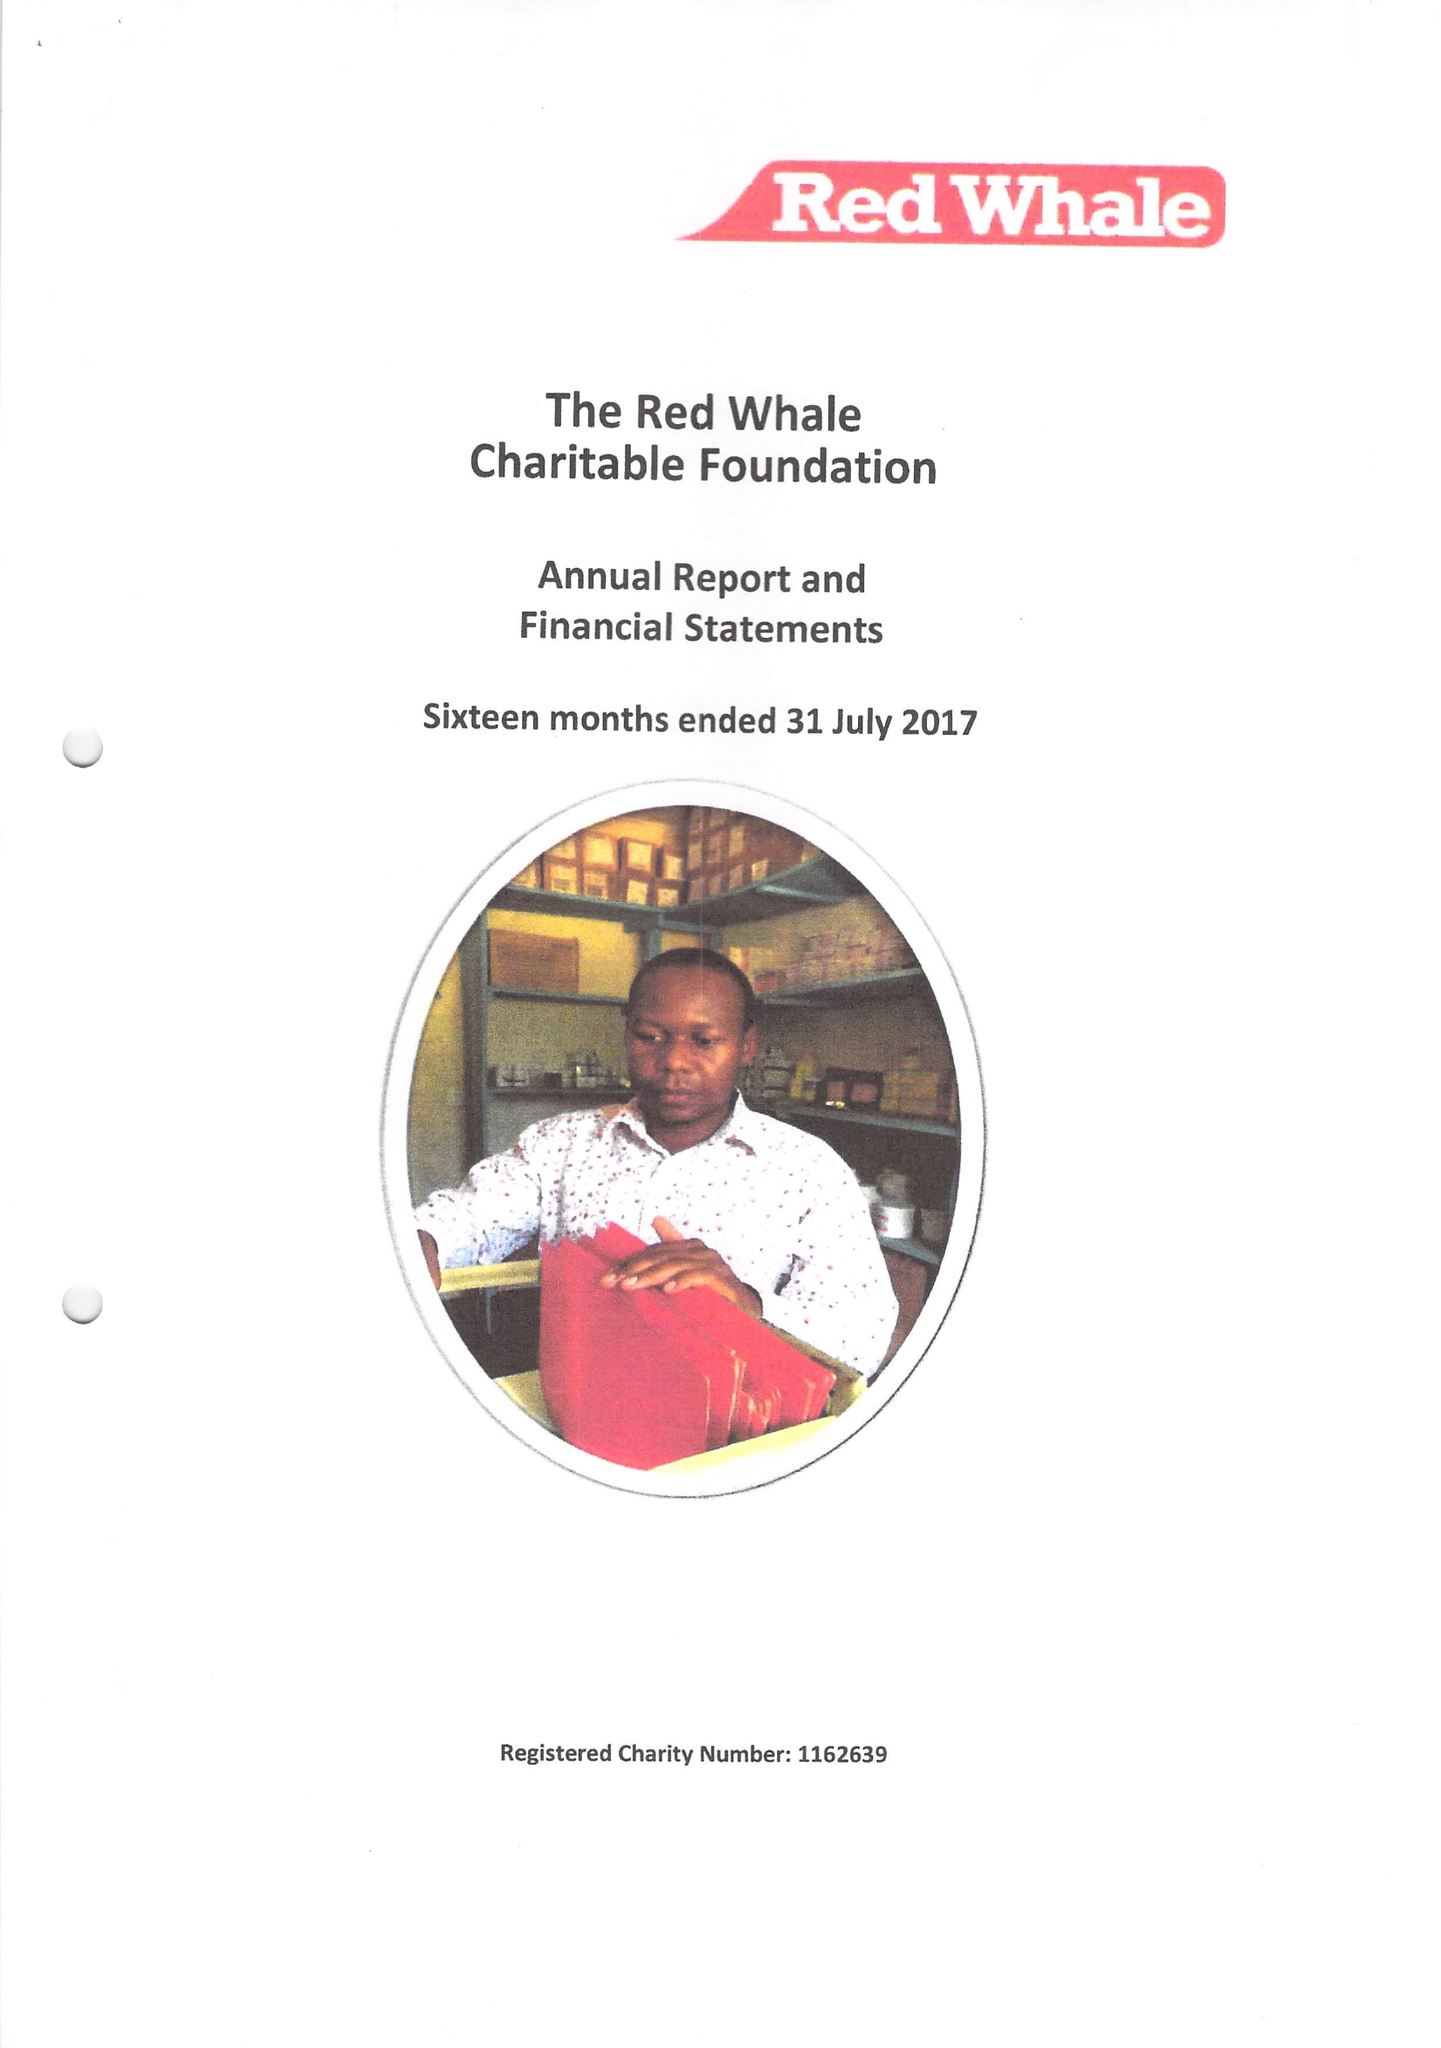What is the value for the address__postcode?
Answer the question using a single word or phrase. RG6 6BU 